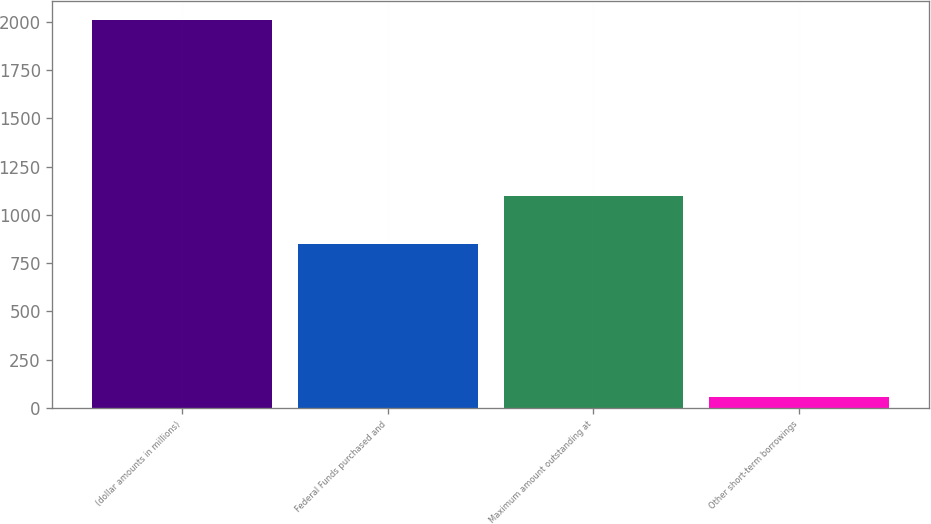Convert chart. <chart><loc_0><loc_0><loc_500><loc_500><bar_chart><fcel>(dollar amounts in millions)<fcel>Federal Funds purchased and<fcel>Maximum amount outstanding at<fcel>Other short-term borrowings<nl><fcel>2009<fcel>851<fcel>1095<fcel>54<nl></chart> 